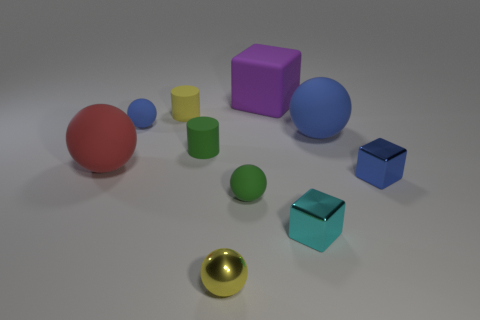Subtract all yellow balls. How many balls are left? 4 Subtract all red spheres. How many spheres are left? 4 Subtract all brown spheres. Subtract all purple blocks. How many spheres are left? 5 Add 7 blue metallic things. How many blue metallic things are left? 8 Add 4 blue matte balls. How many blue matte balls exist? 6 Subtract 0 cyan cylinders. How many objects are left? 10 Subtract all cylinders. How many objects are left? 8 Subtract all big yellow metallic cubes. Subtract all cylinders. How many objects are left? 8 